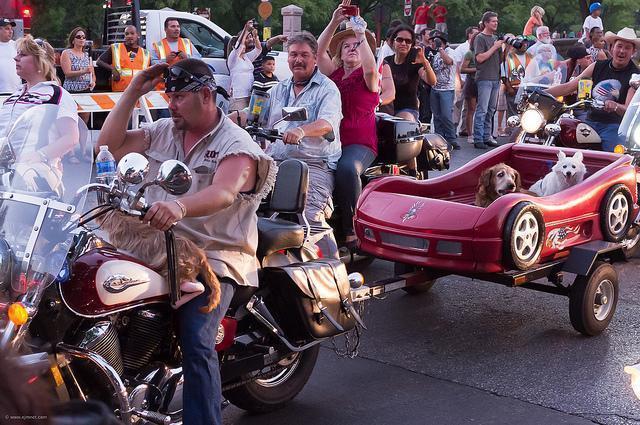The dogs face danger of falling off if the rider does what?
Choose the correct response, then elucidate: 'Answer: answer
Rationale: rationale.'
Options: Stops, speeds, yells, sings. Answer: speeds.
Rationale: If the man goes to fast they could get hurt. 